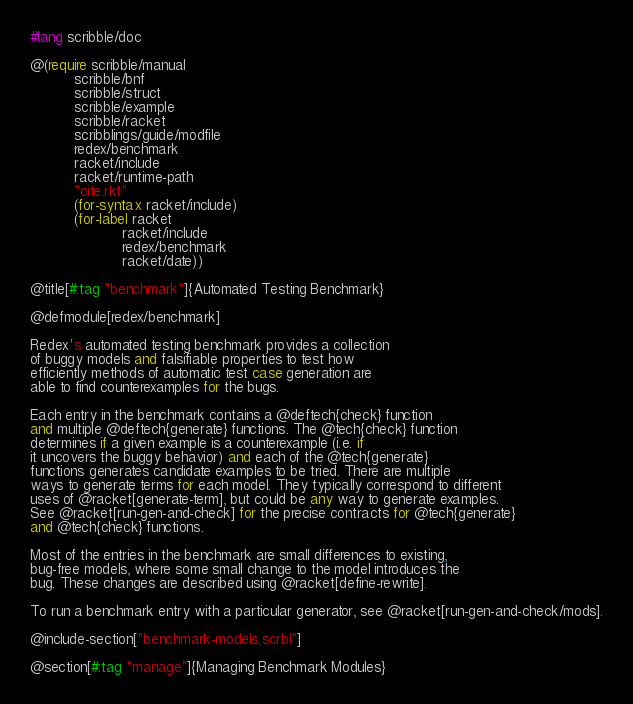<code> <loc_0><loc_0><loc_500><loc_500><_Racket_>#lang scribble/doc

@(require scribble/manual
          scribble/bnf
          scribble/struct
          scribble/example
          scribble/racket
          scribblings/guide/modfile
          redex/benchmark
          racket/include
          racket/runtime-path
          "cite.rkt"
          (for-syntax racket/include)
          (for-label racket
                     racket/include
                     redex/benchmark
                     racket/date))

@title[#:tag "benchmark"]{Automated Testing Benchmark}

@defmodule[redex/benchmark]

Redex's automated testing benchmark provides a collection
of buggy models and falsifiable properties to test how
efficiently methods of automatic test case generation are
able to find counterexamples for the bugs.

Each entry in the benchmark contains a @deftech{check} function
and multiple @deftech{generate} functions. The @tech{check} function
determines if a given example is a counterexample (i.e. if
it uncovers the buggy behavior) and each of the @tech{generate}
functions generates candidate examples to be tried. There are multiple
ways to generate terms for each model. They typically correspond to different
uses of @racket[generate-term], but could be any way to generate examples.
See @racket[run-gen-and-check] for the precise contracts for @tech{generate}
and @tech{check} functions.

Most of the entries in the benchmark are small differences to existing, 
bug-free models, where some small change to the model introduces the
bug. These changes are described using @racket[define-rewrite].

To run a benchmark entry with a particular generator, see @racket[run-gen-and-check/mods].

@include-section["benchmark-models.scrbl"]

@section[#:tag "manage"]{Managing Benchmark Modules}
</code> 